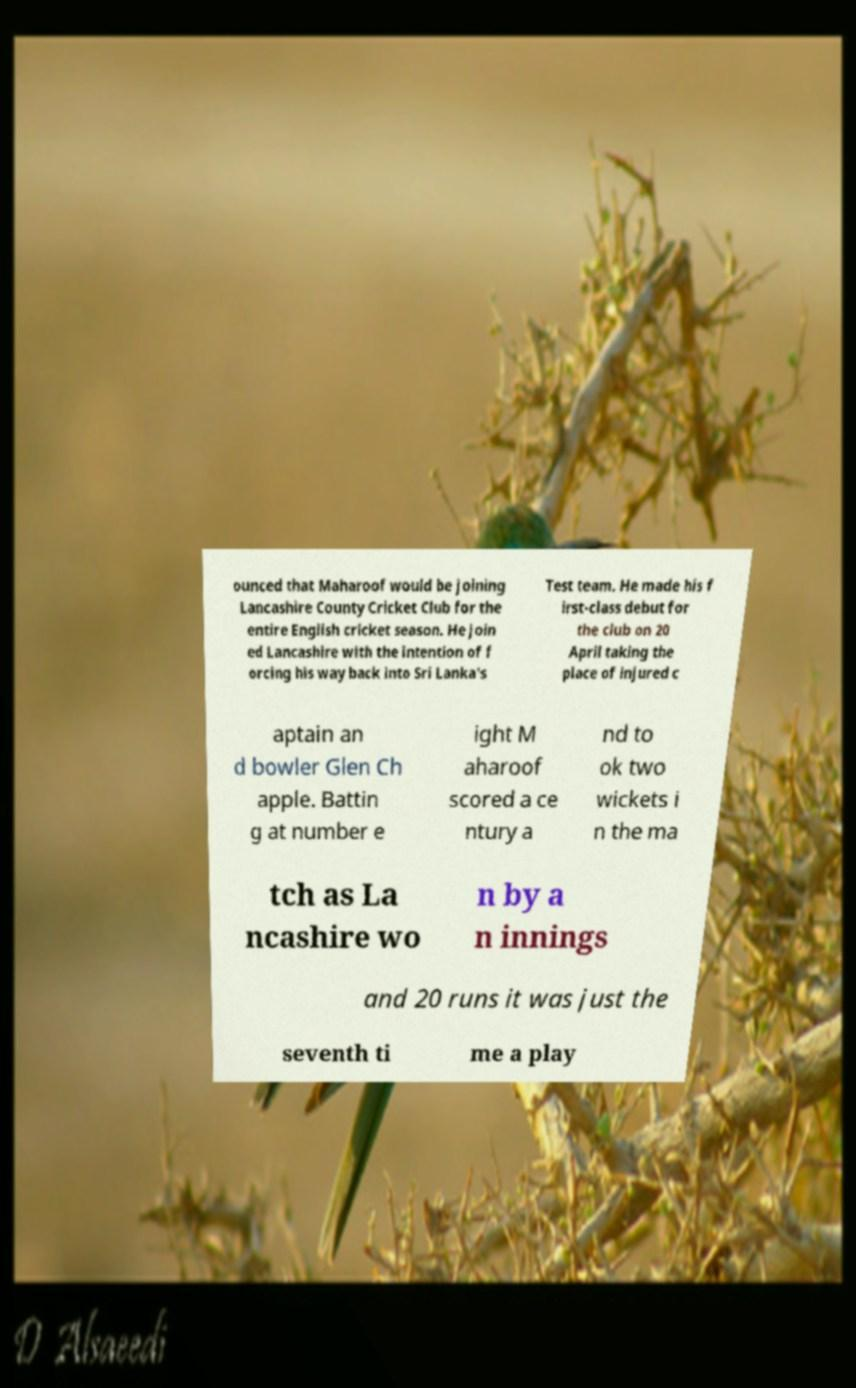Please identify and transcribe the text found in this image. ounced that Maharoof would be joining Lancashire County Cricket Club for the entire English cricket season. He join ed Lancashire with the intention of f orcing his way back into Sri Lanka's Test team. He made his f irst-class debut for the club on 20 April taking the place of injured c aptain an d bowler Glen Ch apple. Battin g at number e ight M aharoof scored a ce ntury a nd to ok two wickets i n the ma tch as La ncashire wo n by a n innings and 20 runs it was just the seventh ti me a play 